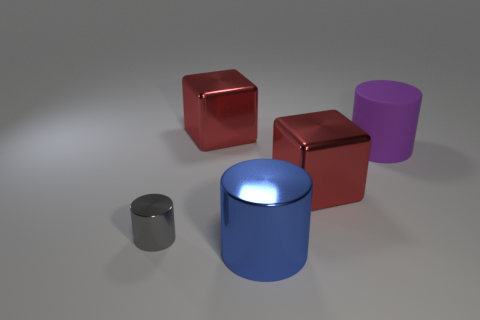What material is the gray object?
Provide a short and direct response. Metal. There is a tiny cylinder behind the blue shiny thing; what number of large metallic cubes are in front of it?
Your answer should be very brief. 0. What is the color of the rubber cylinder that is the same size as the blue object?
Provide a short and direct response. Purple. Is there another gray rubber object of the same shape as the gray thing?
Your answer should be compact. No. Are there fewer gray shiny things than blue blocks?
Your response must be concise. No. What is the color of the thing behind the matte cylinder?
Give a very brief answer. Red. The big red thing that is left of the big shiny cube to the right of the big blue thing is what shape?
Ensure brevity in your answer.  Cube. Is the blue cylinder made of the same material as the cylinder on the right side of the blue metallic object?
Provide a short and direct response. No. What number of shiny cylinders are the same size as the purple thing?
Your answer should be very brief. 1. Are there fewer metal cylinders that are behind the matte thing than cylinders?
Keep it short and to the point. Yes. 